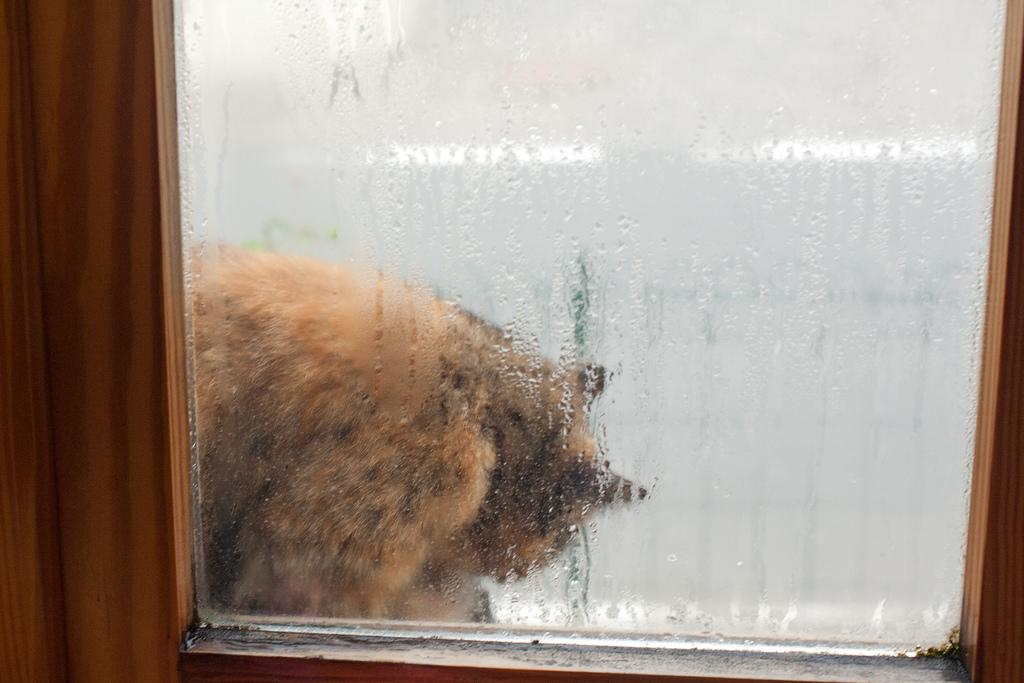What type of structure is present in the image? There is a glass window in the image. What is on the glass window? There are water droplets on the glass window. What can be seen through the glass window? An animal is visible through the glass window. What type of cracker is being held by the animal in the image? There is no cracker present in the image, and the animal's actions are not described. 